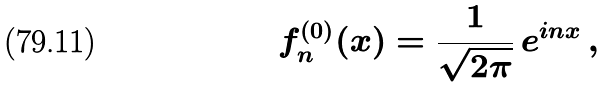Convert formula to latex. <formula><loc_0><loc_0><loc_500><loc_500>f _ { n } ^ { ( 0 ) } ( x ) = \frac { 1 } { \sqrt { 2 \pi } } \, e ^ { i n x } \, ,</formula> 